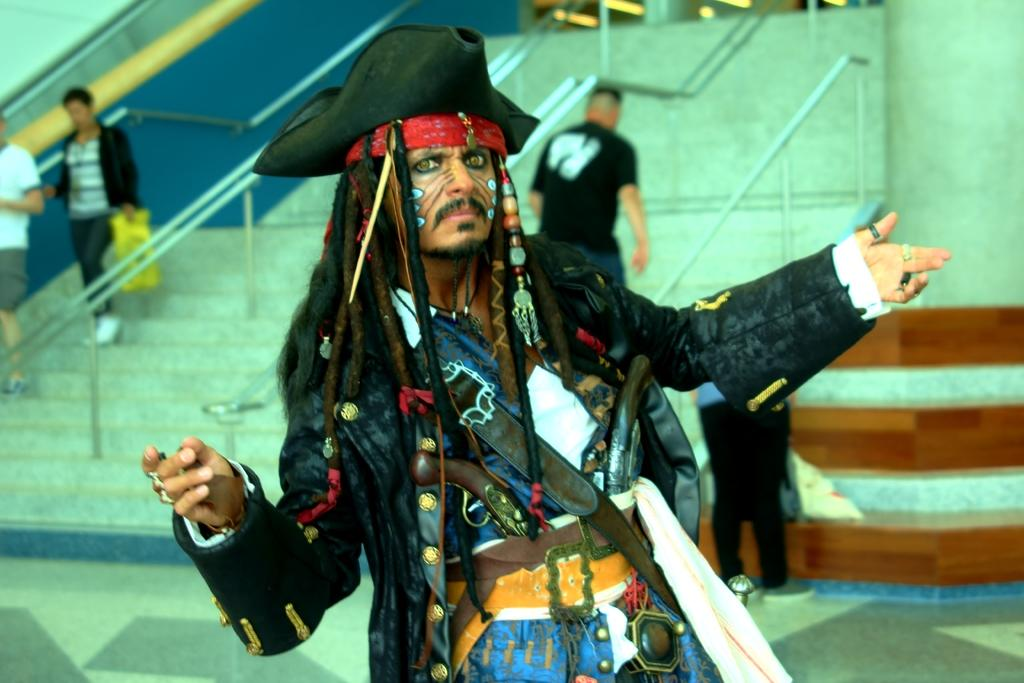What is the appearance of the person in the image? There is a man in the image, and he is wearing a pirate costume. How many people are present in the image? There are three people in the image. What are the three people doing in the image? The three people are taking the stairs. What type of pie is being served to the pirate in the image? There is no pie present in the image; the man is wearing a pirate costume, but there is no indication of any food being served. 